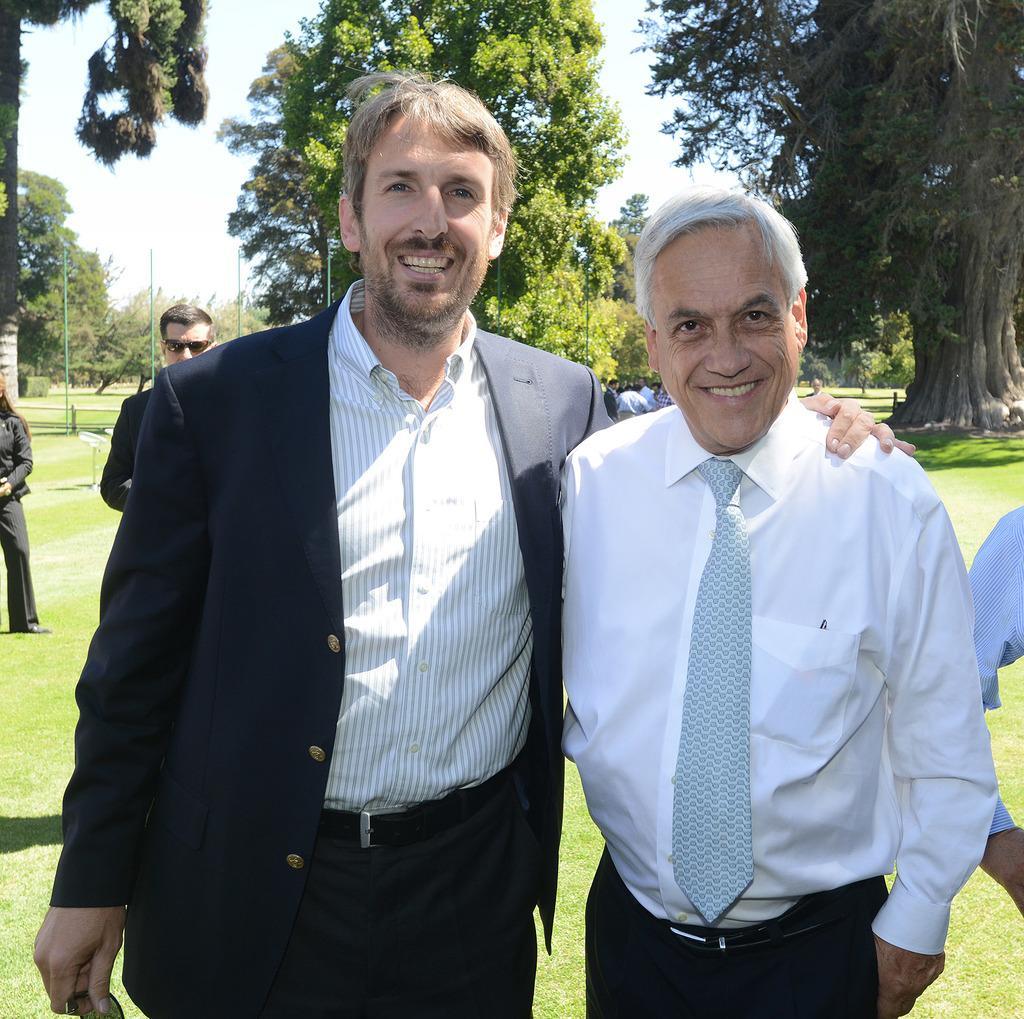Describe this image in one or two sentences. In this picture we can see group of people, they are standing on the grass, in the background we can find few trees and poles. 